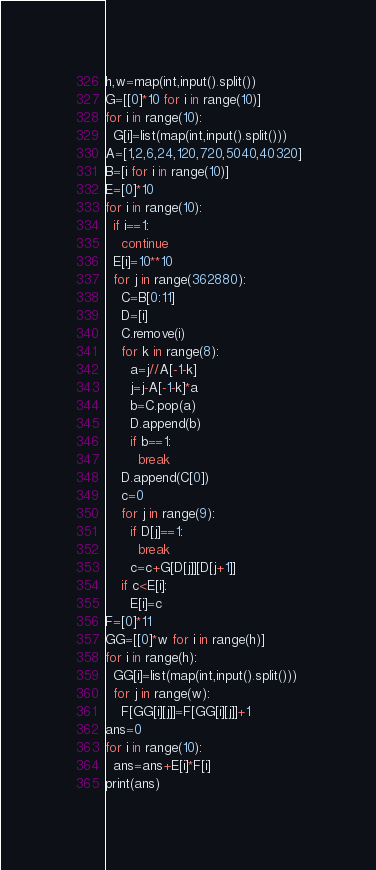Convert code to text. <code><loc_0><loc_0><loc_500><loc_500><_Python_>h,w=map(int,input().split())
G=[[0]*10 for i in range(10)]
for i in range(10):
  G[i]=list(map(int,input().split()))
A=[1,2,6,24,120,720,5040,40320]
B=[i for i in range(10)]
E=[0]*10
for i in range(10):
  if i==1:
    continue
  E[i]=10**10
  for j in range(362880):
    C=B[0:11]
    D=[i]
    C.remove(i)
    for k in range(8):
      a=j//A[-1-k]
      j=j-A[-1-k]*a
      b=C.pop(a)
      D.append(b)
      if b==1:
        break
    D.append(C[0])
    c=0
    for j in range(9):
      if D[j]==1:
        break
      c=c+G[D[j]][D[j+1]]
    if c<E[i]:
      E[i]=c
F=[0]*11
GG=[[0]*w for i in range(h)]
for i in range(h):
  GG[i]=list(map(int,input().split()))
  for j in range(w):
    F[GG[i][j]]=F[GG[i][j]]+1
ans=0
for i in range(10):
  ans=ans+E[i]*F[i]
print(ans)</code> 